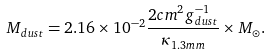Convert formula to latex. <formula><loc_0><loc_0><loc_500><loc_500>M _ { d u s t } = 2 . 1 6 \times 1 0 ^ { - 2 } \frac { 2 c m ^ { 2 } g { ^ { - 1 } _ { d u s t } } } { \kappa _ { 1 . 3 m m } } \times M _ { \odot } .</formula> 